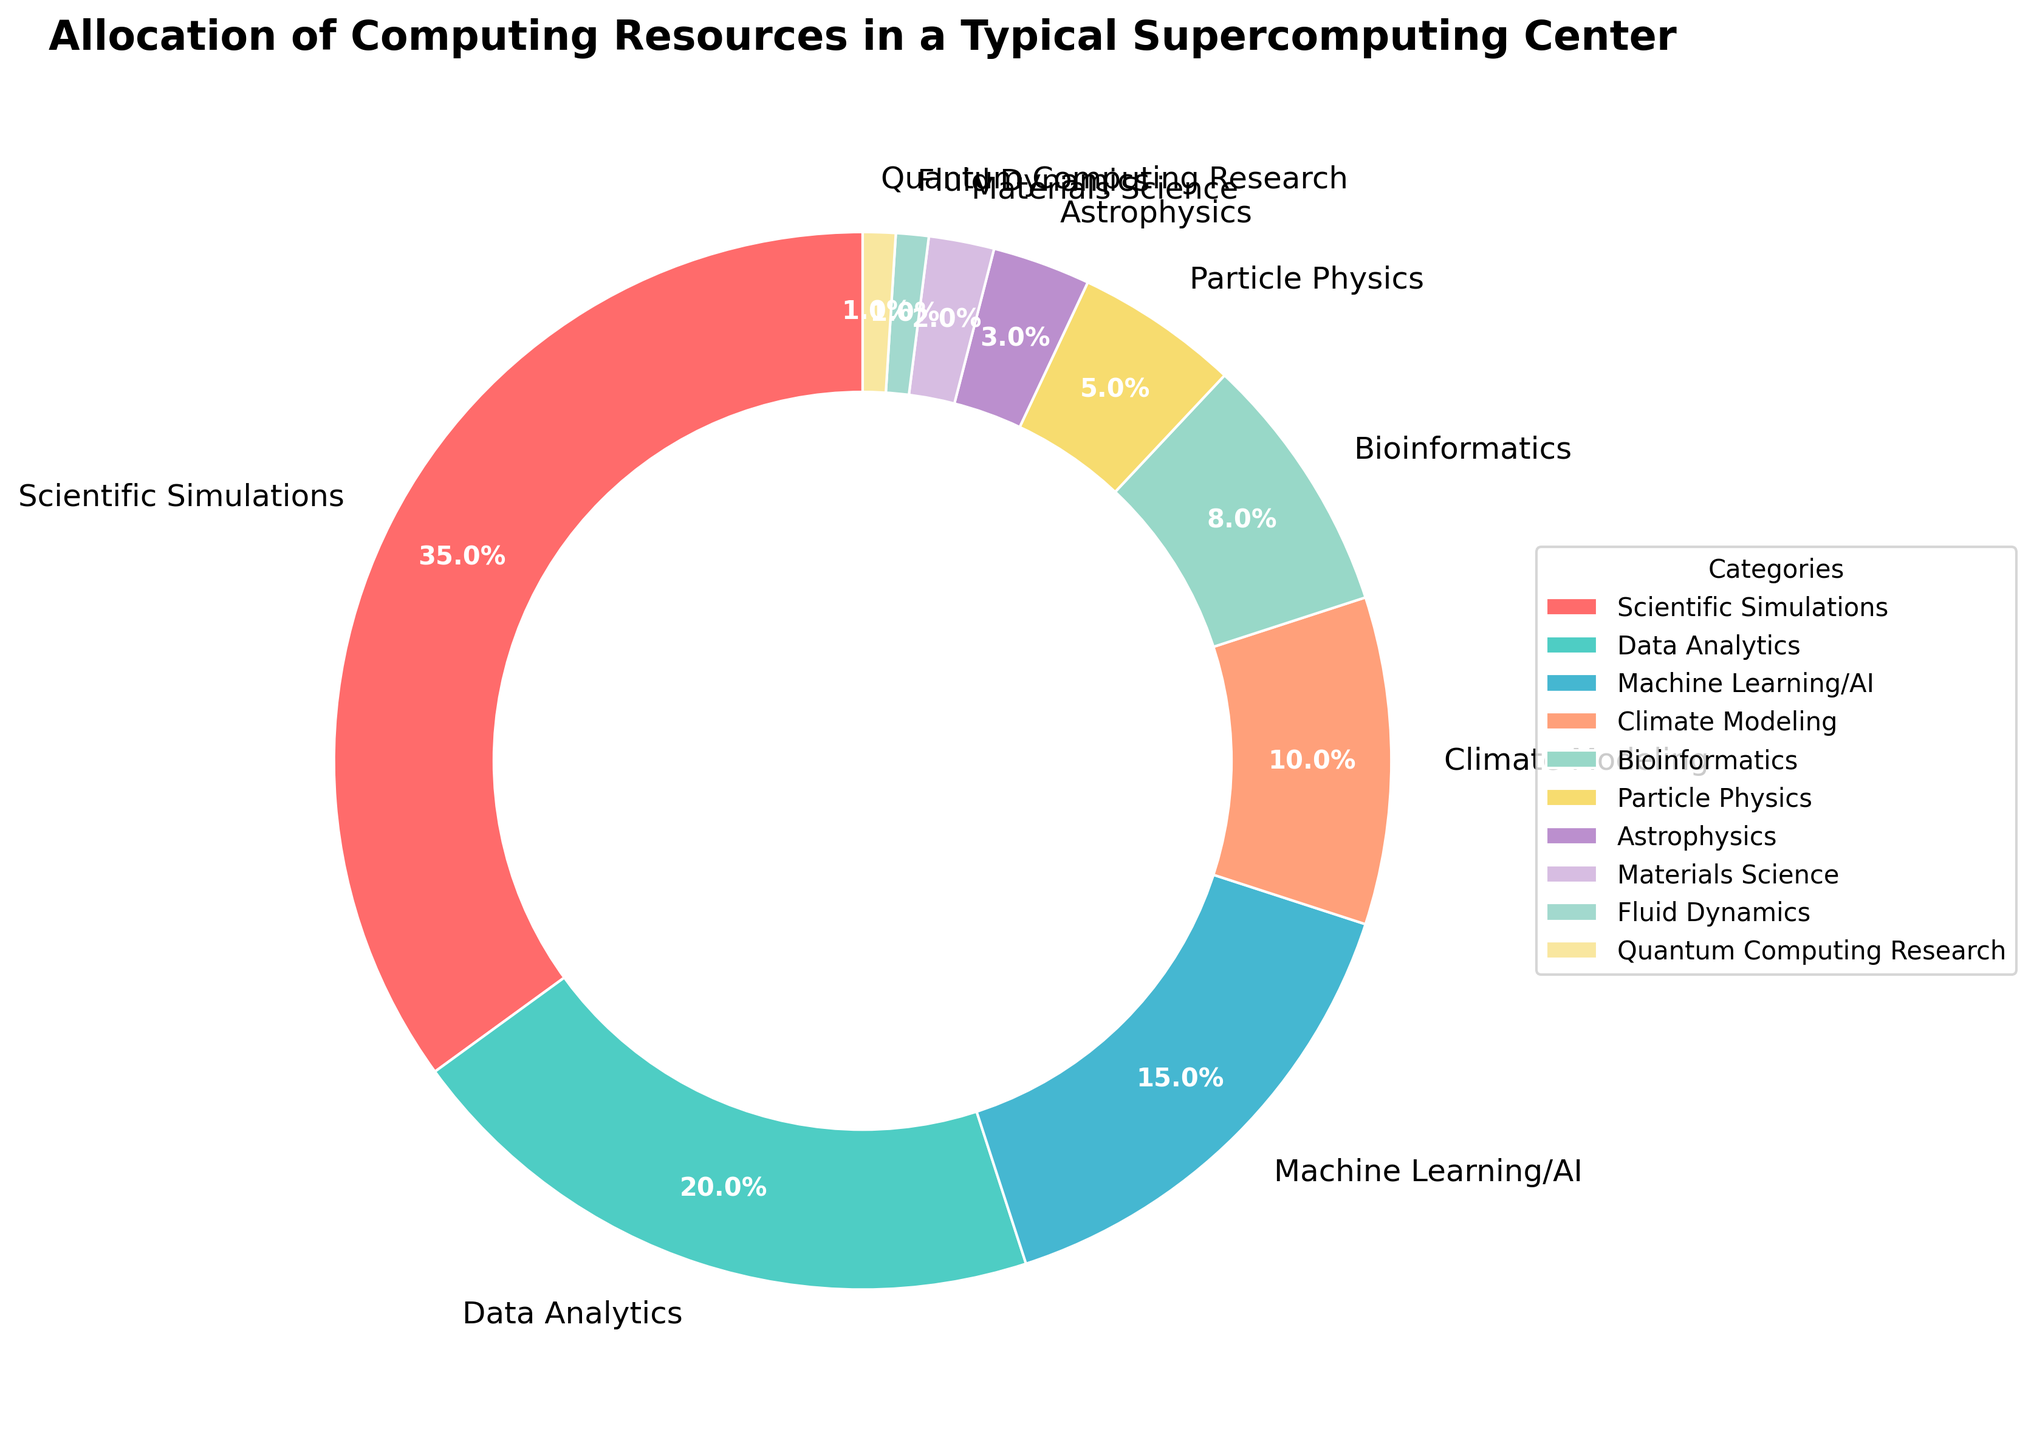What category has the largest allocation of computing resources? The segment with the largest percentage is labeled as "Scientific Simulations" with 35%.
Answer: Scientific Simulations What is the combined percentage of resources dedicated to Data Analytics and Machine Learning/AI? Data Analytics has 20% and Machine Learning/AI has 15%. Summing these gives 20% + 15% = 35%.
Answer: 35% Which categories combined account for less than 10% of the resources? The categories contributing less than 10% each are Materials Science (2%), Fluid Dynamics (1%), and Quantum Computing Research (1%).
Answer: Materials Science, Fluid Dynamics, Quantum Computing Research How much more computing resources are allocated to Climate Modeling compared to Bioinformatics? Climate Modeling has 10%, and Bioinformatics has 8%. The difference is 10% - 8% = 2%.
Answer: 2% Which category is represented by the yellow segment, and what is its percentage? The yellow segment is labeled as "Climate Modeling" which has a percentage of 10%.
Answer: Climate Modeling, 10% What is the percentage difference between Scientific Simulations and Particle Physics? Scientific Simulations has 35%, and Particle Physics has 5%. The difference is 35% - 5% = 30%.
Answer: 30% List all categories that individually account for more resources than Astrophysics. Scientific Simulations (35%), Data Analytics (20%), Machine Learning/AI (15%), Climate Modeling (10%), and Bioinformatics (8%) all have percentages greater than Astrophysics (3%).
Answer: Scientific Simulations, Data Analytics, Machine Learning/AI, Climate Modeling, Bioinformatics What is the total percentage of computing resources used by Particle Physics and Astrophysics combined? Particle Physics has 5% and Astrophysics has 3%. Adding these gives 5% + 3% = 8%.
Answer: 8% What fraction of the total resources is allocated to categories with less than or equal to 5% each? Particle Physics (5%), Astrophysics (3%), Materials Science (2%), Fluid Dynamics (1%), and Quantum Computing Research (1%). Summing these gives 5% + 3% + 2% + 1% + 1% = 12%.
Answer: 12% 